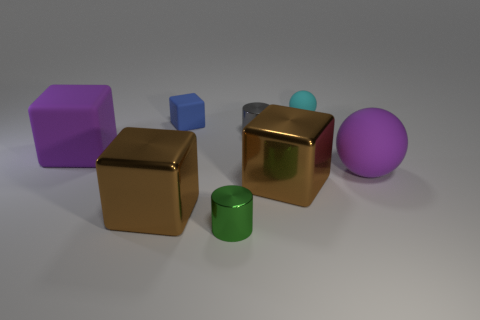What is the material of the gray object that is the same size as the cyan thing?
Your response must be concise. Metal. How many tiny things are either gray matte spheres or metal cylinders?
Ensure brevity in your answer.  2. Is the shape of the small cyan matte thing the same as the tiny gray object?
Provide a succinct answer. No. What number of large things are in front of the large rubber sphere and right of the blue matte block?
Make the answer very short. 1. Is there anything else of the same color as the tiny cube?
Keep it short and to the point. No. What is the shape of the tiny cyan thing that is the same material as the purple ball?
Your response must be concise. Sphere. Does the green shiny thing have the same size as the gray metallic object?
Your answer should be very brief. Yes. Does the object behind the tiny block have the same material as the tiny green cylinder?
Keep it short and to the point. No. Is there anything else that is the same material as the gray object?
Ensure brevity in your answer.  Yes. There is a big shiny cube that is left of the large shiny block that is right of the small green cylinder; what number of brown shiny cubes are on the right side of it?
Your response must be concise. 1. 